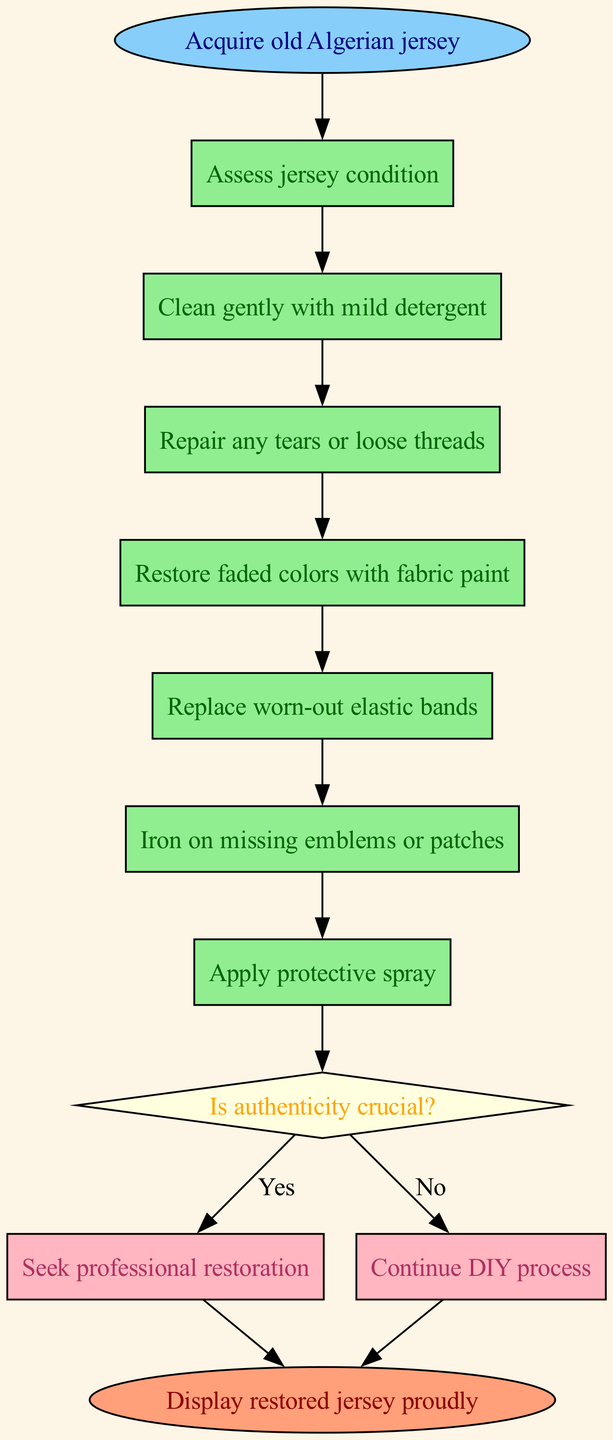What is the first step in the process? The diagram starts with the node labeled "Acquire old Algerian jersey," indicating that it is the first step in the restoration process.
Answer: Acquire old Algerian jersey How many total steps are there in the process? The process includes a total of seven steps, which are outlined in the "steps" section of the diagram.
Answer: Seven What is the condition for the decision node? The decision node asks, "Is authenticity crucial?", which is the condition determining whether to seek professional restoration or to continue with the DIY process.
Answer: Is authenticity crucial? If authenticity is not crucial, what is the next step? If the answer to the decision node is "No," the flow continues down to "Continue DIY process," indicating the next course of action in the diagram.
Answer: Continue DIY process What color represents the repair step? The step labeled "Repair any tears or loose threads" is represented in light green, which is the color assigned to all the steps in the diagram.
Answer: Light green What action is taken if the authenticity is crucial? If the decision node leads to "Yes" for authenticity being crucial, the next action specified is "Seek professional restoration."
Answer: Seek professional restoration How does the process conclude? The process concludes at the node labeled "Display restored jersey proudly," which signifies the end of the restoration steps.
Answer: Display restored jersey proudly What color are the decision outcomes shown in? The outcomes for the decision are shown in light pink, which is the color designated for the nodes representing the possible outcomes of the decision.
Answer: Light pink Which step comes before applying the protective spray? The step prior to "Apply protective spray" is "Iron on missing emblems or patches," which indicates the sequence leading up to the final protective measure.
Answer: Iron on missing emblems or patches 